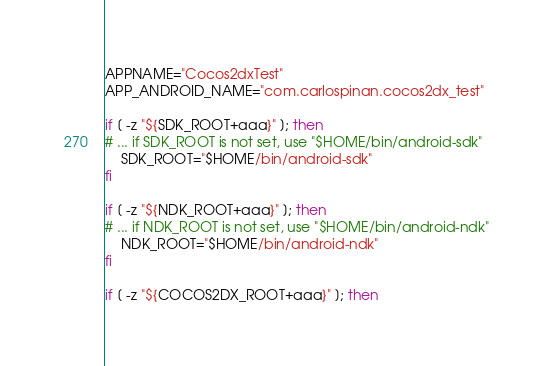Convert code to text. <code><loc_0><loc_0><loc_500><loc_500><_Bash_>APPNAME="Cocos2dxTest"
APP_ANDROID_NAME="com.carlospinan.cocos2dx_test"

if [ -z "${SDK_ROOT+aaa}" ]; then
# ... if SDK_ROOT is not set, use "$HOME/bin/android-sdk"
    SDK_ROOT="$HOME/bin/android-sdk"
fi

if [ -z "${NDK_ROOT+aaa}" ]; then
# ... if NDK_ROOT is not set, use "$HOME/bin/android-ndk"
    NDK_ROOT="$HOME/bin/android-ndk"
fi

if [ -z "${COCOS2DX_ROOT+aaa}" ]; then</code> 